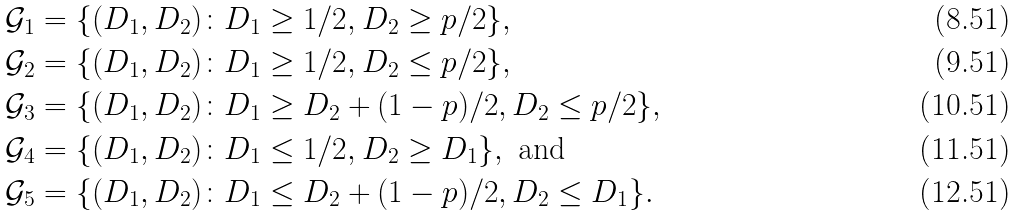Convert formula to latex. <formula><loc_0><loc_0><loc_500><loc_500>\mathcal { G } _ { 1 } & = \{ ( D _ { 1 } , D _ { 2 } ) \colon D _ { 1 } \geq 1 / 2 , D _ { 2 } \geq p / 2 \} , \\ \mathcal { G } _ { 2 } & = \{ ( D _ { 1 } , D _ { 2 } ) \colon D _ { 1 } \geq 1 / 2 , D _ { 2 } \leq p / 2 \} , \\ \mathcal { G } _ { 3 } & = \{ ( D _ { 1 } , D _ { 2 } ) \colon D _ { 1 } \geq D _ { 2 } + ( 1 - p ) / 2 , D _ { 2 } \leq p / 2 \} , \\ \mathcal { G } _ { 4 } & = \{ ( D _ { 1 } , D _ { 2 } ) \colon D _ { 1 } \leq 1 / 2 , D _ { 2 } \geq D _ { 1 } \} , \text { and} \\ \mathcal { G } _ { 5 } & = \{ ( D _ { 1 } , D _ { 2 } ) \colon D _ { 1 } \leq D _ { 2 } + ( 1 - p ) / 2 , D _ { 2 } \leq D _ { 1 } \} .</formula> 